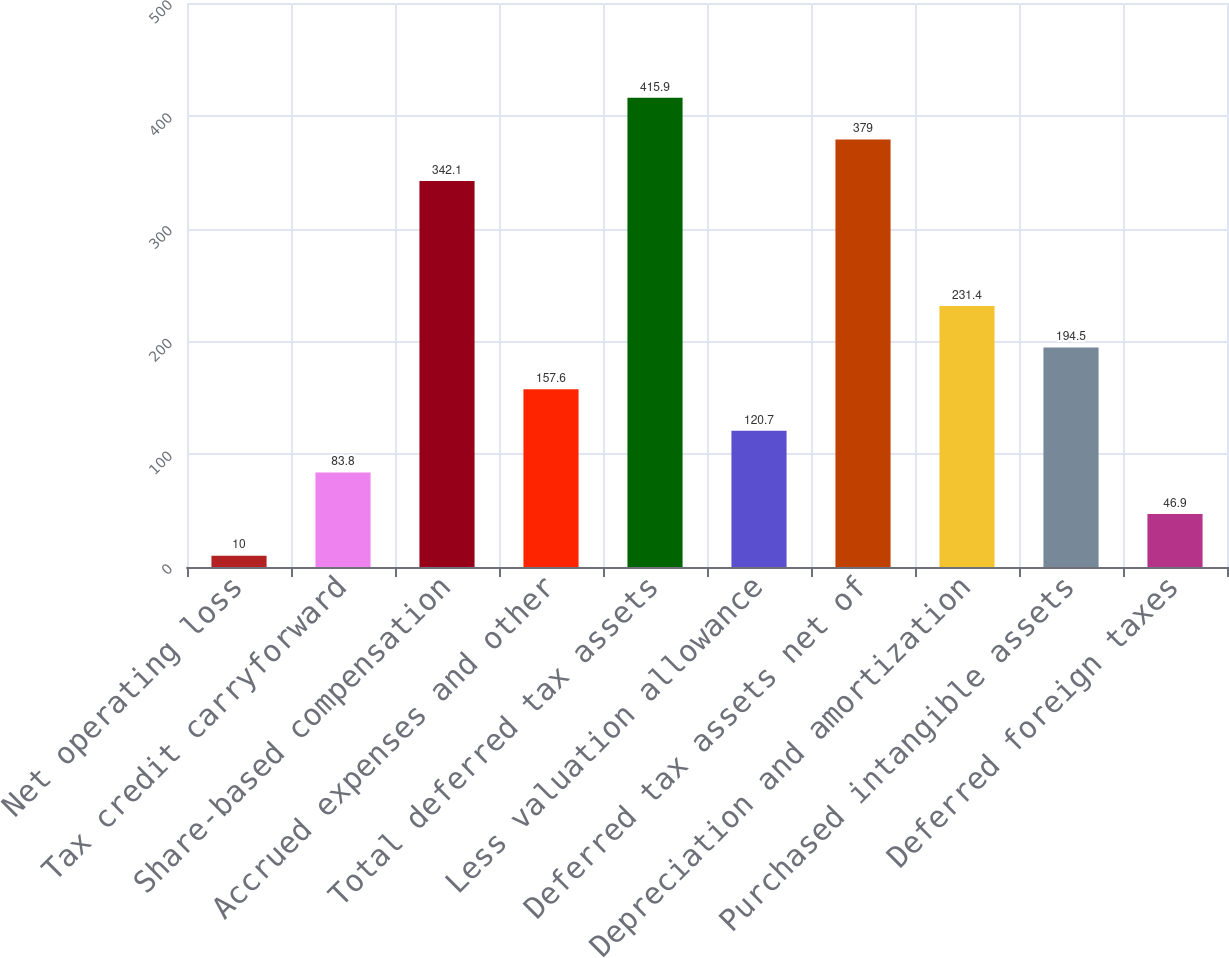Convert chart. <chart><loc_0><loc_0><loc_500><loc_500><bar_chart><fcel>Net operating loss<fcel>Tax credit carryforward<fcel>Share-based compensation<fcel>Accrued expenses and other<fcel>Total deferred tax assets<fcel>Less valuation allowance<fcel>Deferred tax assets net of<fcel>Depreciation and amortization<fcel>Purchased intangible assets<fcel>Deferred foreign taxes<nl><fcel>10<fcel>83.8<fcel>342.1<fcel>157.6<fcel>415.9<fcel>120.7<fcel>379<fcel>231.4<fcel>194.5<fcel>46.9<nl></chart> 